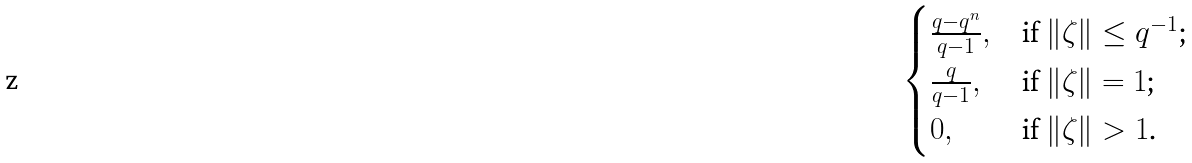Convert formula to latex. <formula><loc_0><loc_0><loc_500><loc_500>\begin{cases} \frac { q - q ^ { n } } { q - 1 } , & \text {if $\|\zeta \|\leq q^{-1}$;} \\ \frac { q } { q - 1 } , & \text {if $\|\zeta \|=1$;} \\ 0 , & \text {if $\|\zeta \|>1$.} \end{cases}</formula> 